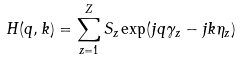Convert formula to latex. <formula><loc_0><loc_0><loc_500><loc_500>H ( q , k ) = \sum _ { z = 1 } ^ { Z } S _ { z } \exp ( j q \gamma _ { z } - j k \eta _ { z } )</formula> 